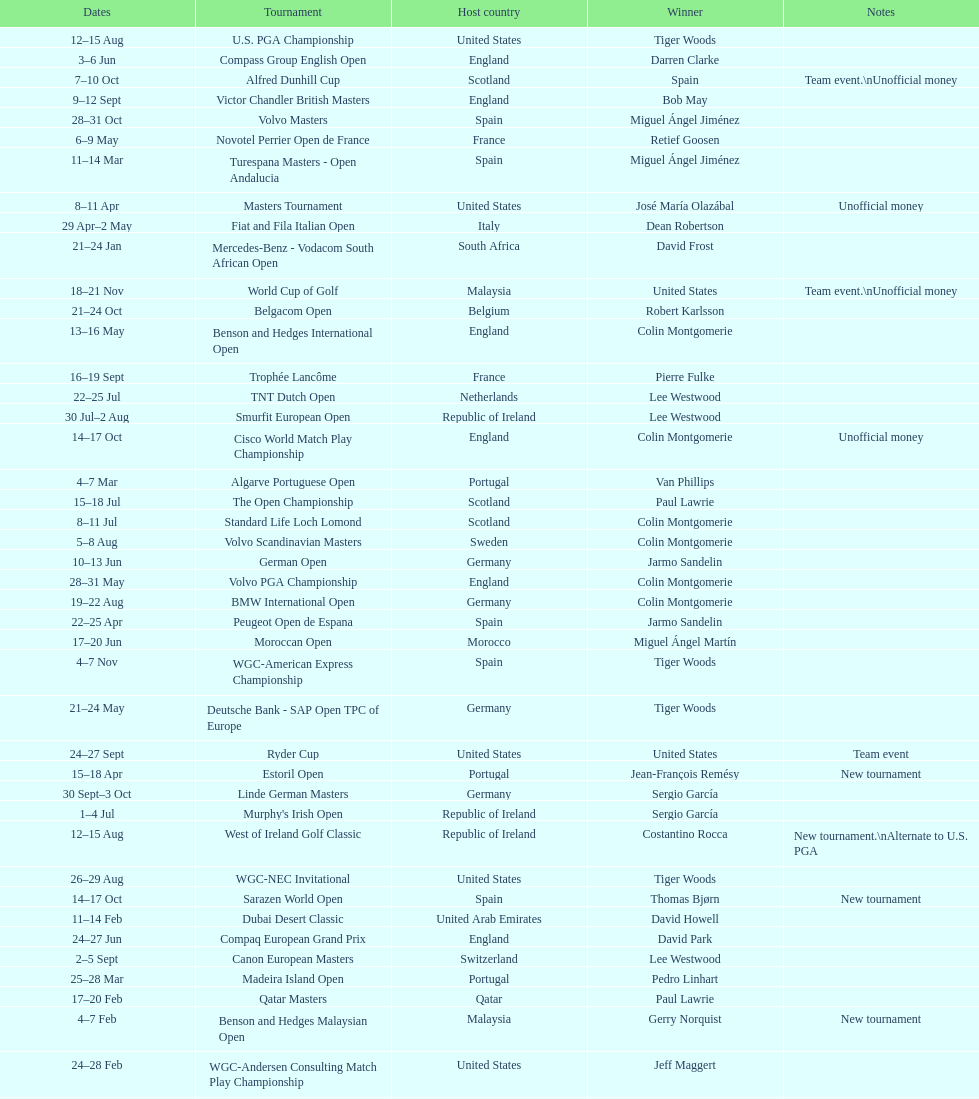What was the country listed the first time there was a new tournament? Malaysia. 